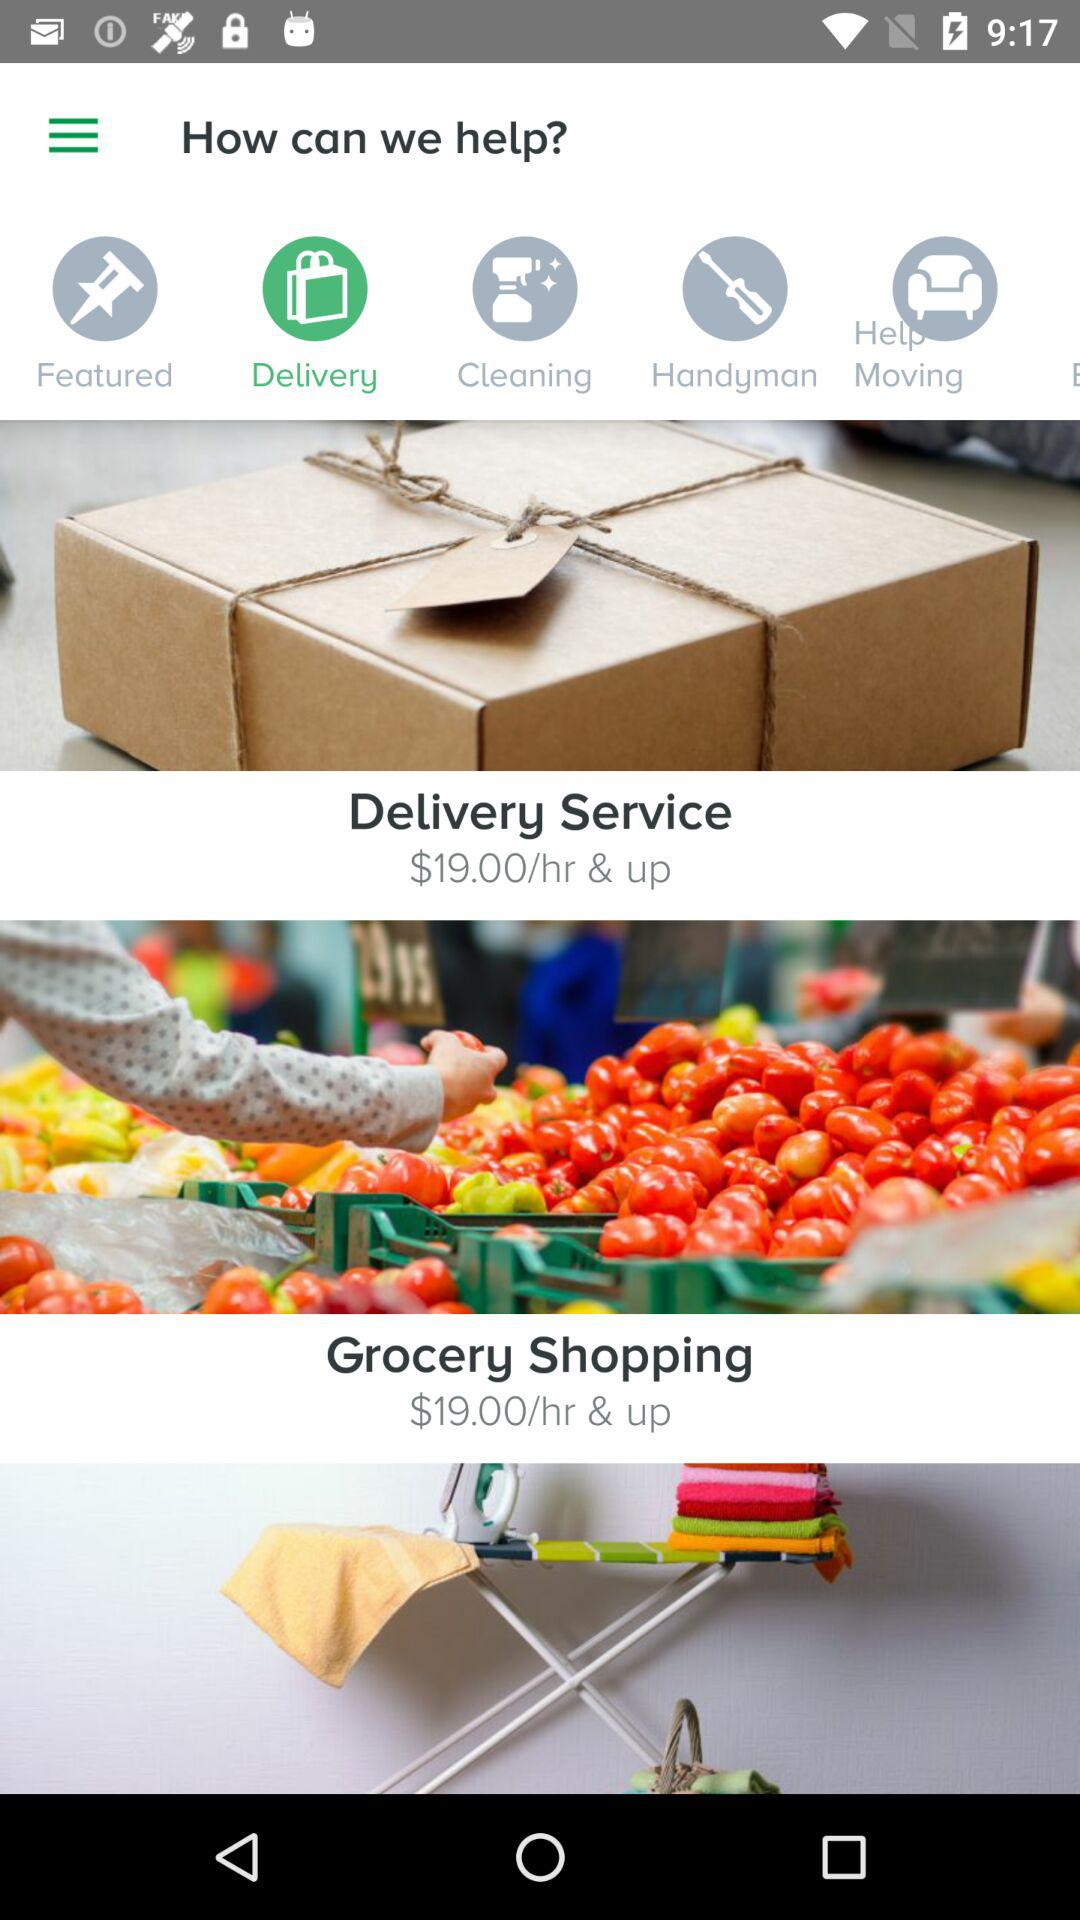What are the services available in "How can we help"? The available services are "Delivery", "Cleaning", "Handyman", and "Help Moving". 